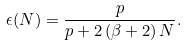<formula> <loc_0><loc_0><loc_500><loc_500>\epsilon ( N ) = \frac { p } { p + 2 \left ( \beta + 2 \right ) N } .</formula> 